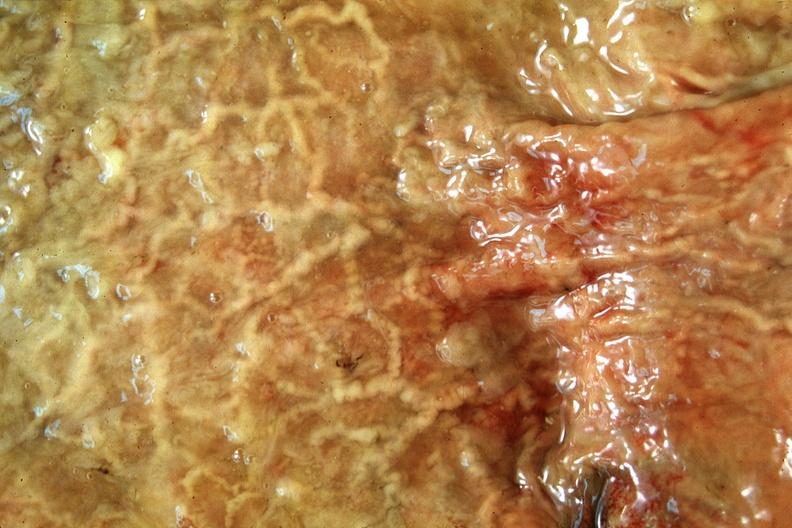what does this image show?
Answer the question using a single word or phrase. Normal stomach 